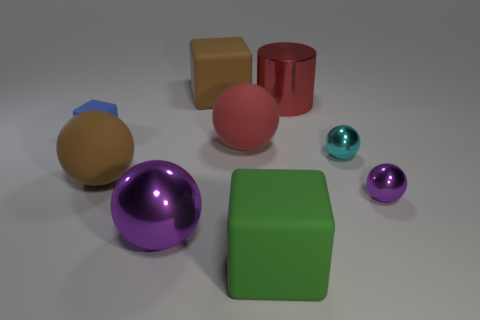Subtract all brown rubber blocks. How many blocks are left? 2 Subtract all red cylinders. How many purple spheres are left? 2 Add 1 green cubes. How many objects exist? 10 Subtract all purple spheres. How many spheres are left? 3 Subtract 2 balls. How many balls are left? 3 Subtract all cubes. How many objects are left? 6 Subtract all cyan blocks. Subtract all blue spheres. How many blocks are left? 3 Subtract all green cubes. Subtract all large brown matte things. How many objects are left? 6 Add 4 tiny cyan spheres. How many tiny cyan spheres are left? 5 Add 6 yellow objects. How many yellow objects exist? 6 